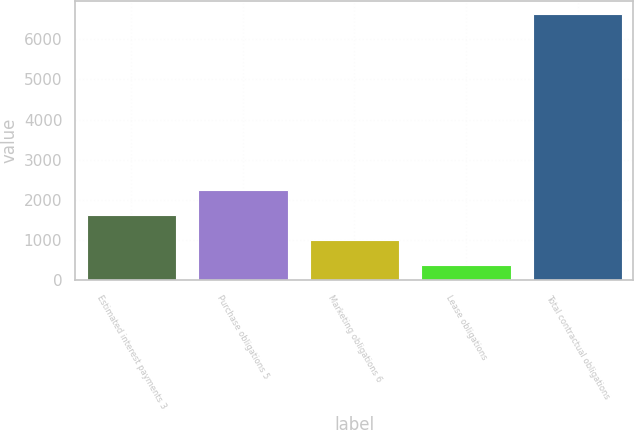<chart> <loc_0><loc_0><loc_500><loc_500><bar_chart><fcel>Estimated interest payments 3<fcel>Purchase obligations 5<fcel>Marketing obligations 6<fcel>Lease obligations<fcel>Total contractual obligations<nl><fcel>1634.6<fcel>2258.4<fcel>1010.8<fcel>387<fcel>6625<nl></chart> 